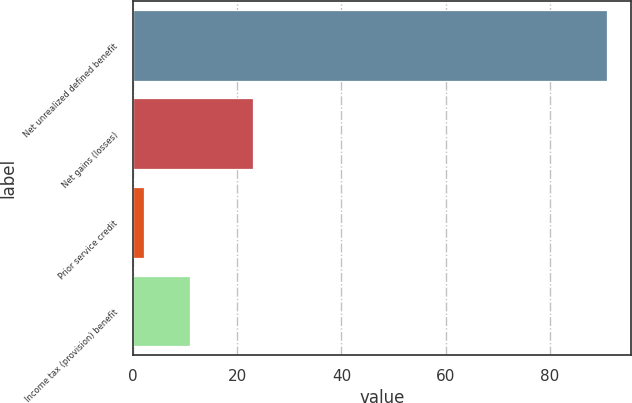Convert chart. <chart><loc_0><loc_0><loc_500><loc_500><bar_chart><fcel>Net unrealized defined benefit<fcel>Net gains (losses)<fcel>Prior service credit<fcel>Income tax (provision) benefit<nl><fcel>91<fcel>23<fcel>2<fcel>10.9<nl></chart> 